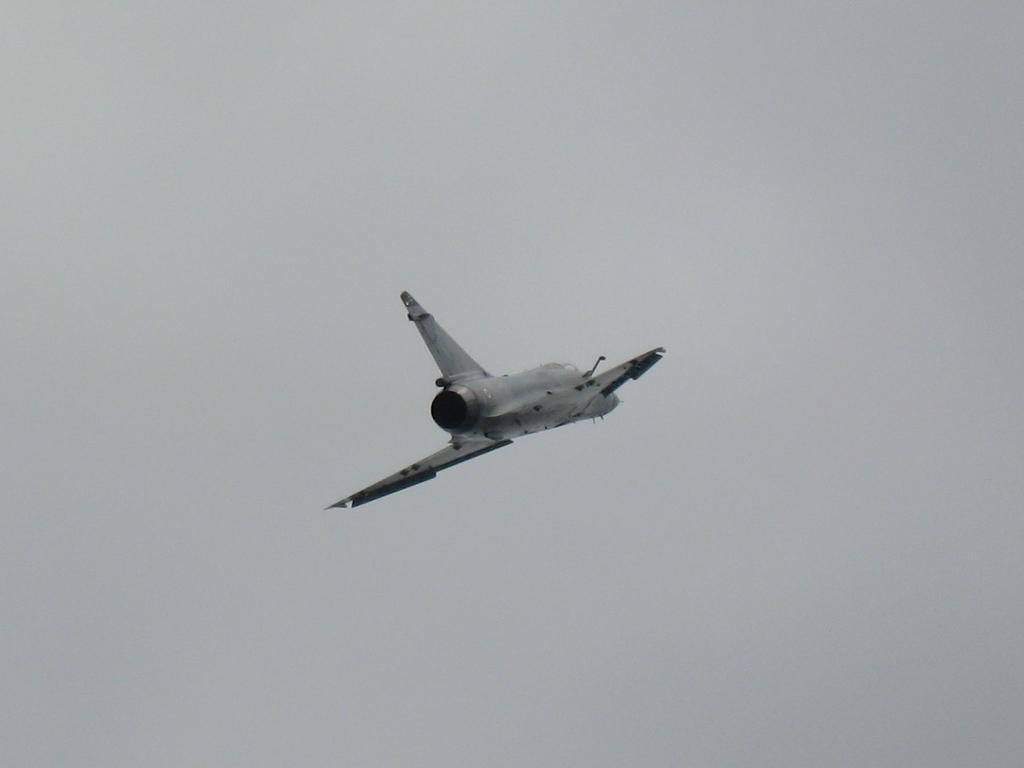In one or two sentences, can you explain what this image depicts? In the center of the image there is a spacecraft in the air. In the background there is sky. 